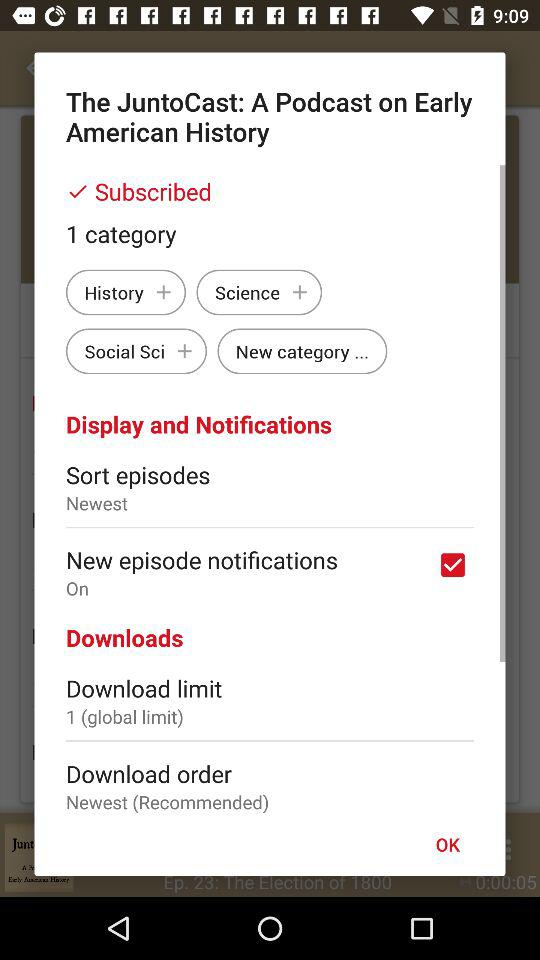How many download limits are there?
Answer the question using a single word or phrase. 1 